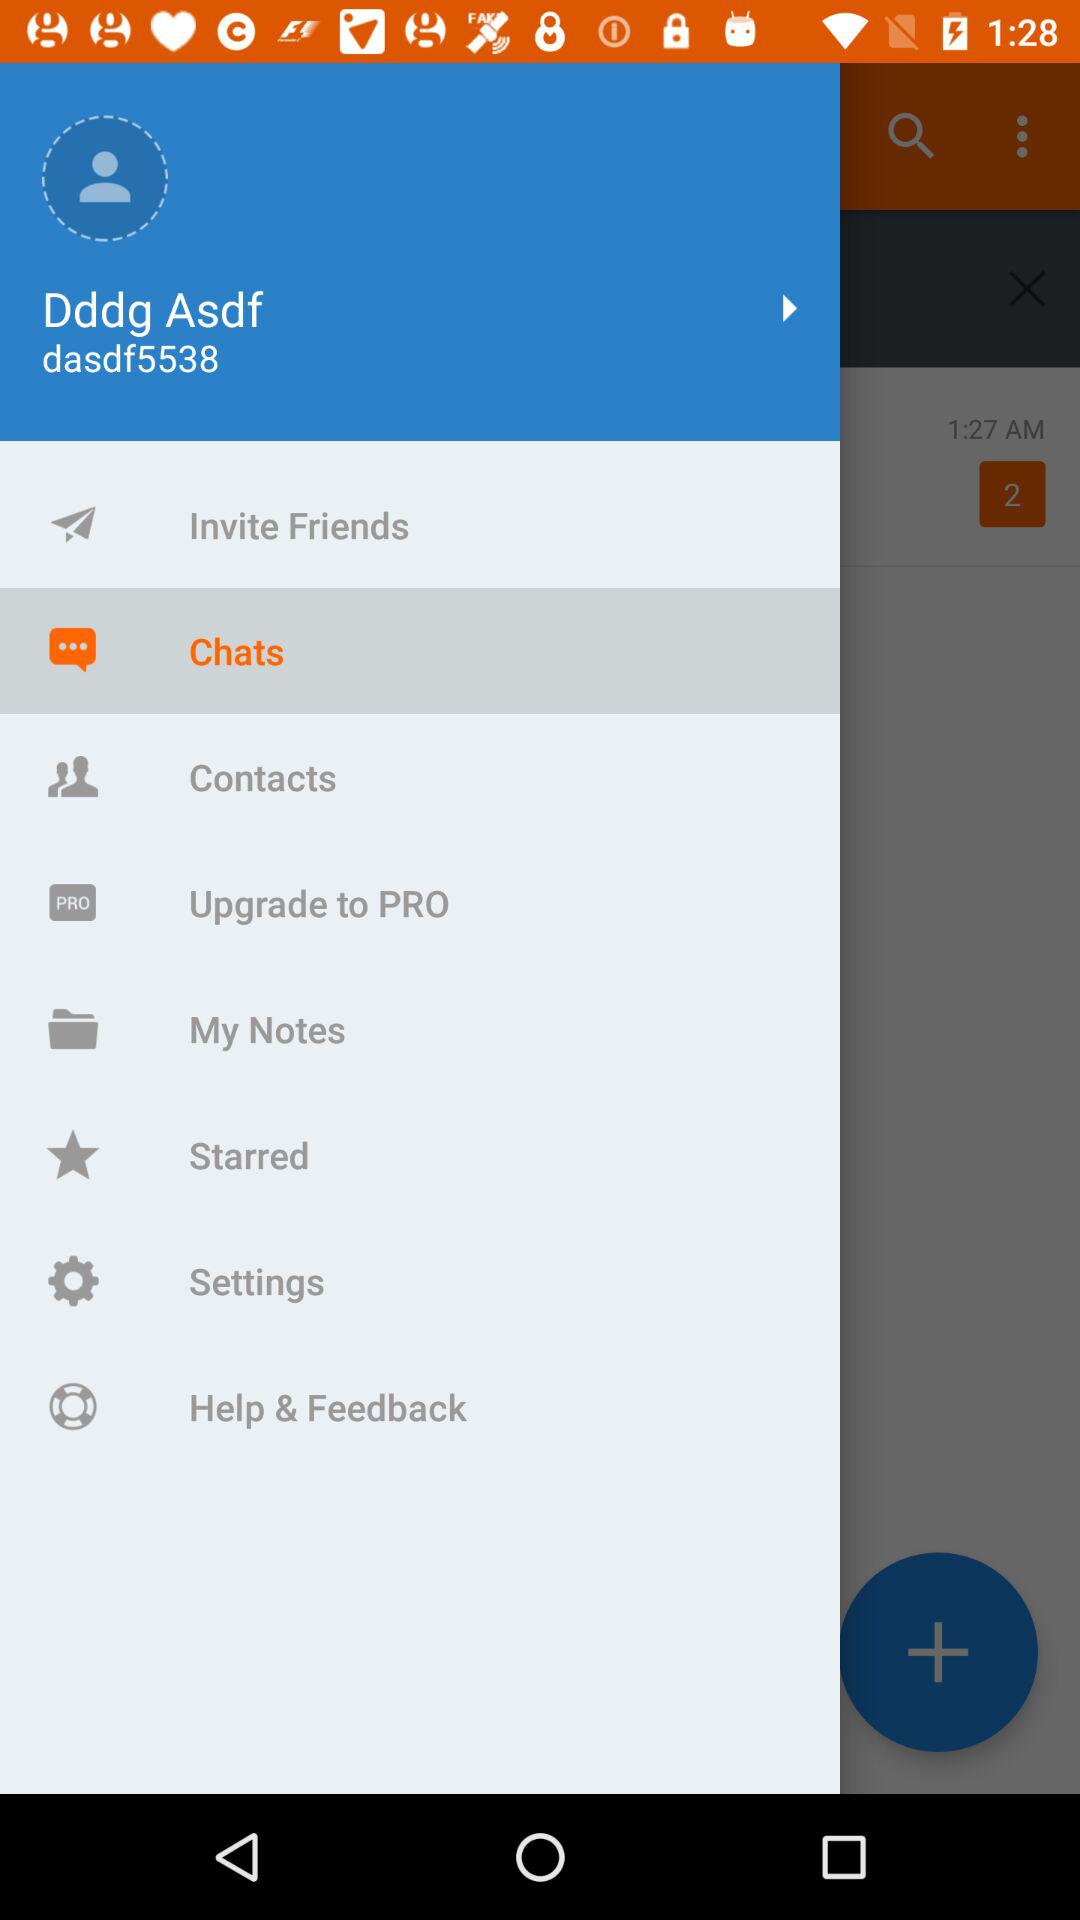What is the selected item in the menu? The selected item is "Chats". 